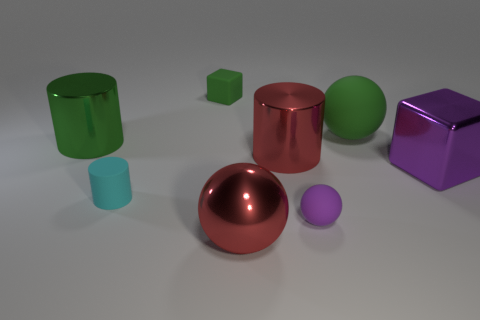What material is the purple object that is the same size as the red shiny cylinder?
Keep it short and to the point. Metal. What number of metal objects are either green spheres or tiny gray cylinders?
Keep it short and to the point. 0. There is a sphere that is in front of the large green rubber sphere and behind the metal sphere; what color is it?
Your answer should be very brief. Purple. How many balls are in front of the large purple shiny cube?
Keep it short and to the point. 2. What is the large green cylinder made of?
Make the answer very short. Metal. The big object that is in front of the big metallic thing to the right of the red metallic thing behind the small purple rubber sphere is what color?
Keep it short and to the point. Red. What number of purple matte balls have the same size as the shiny ball?
Provide a short and direct response. 0. What is the color of the metal cylinder on the right side of the green cube?
Your answer should be very brief. Red. How many other objects are there of the same size as the red metallic sphere?
Make the answer very short. 4. How big is the metal thing that is both on the right side of the big green metallic cylinder and behind the purple metallic cube?
Keep it short and to the point. Large. 